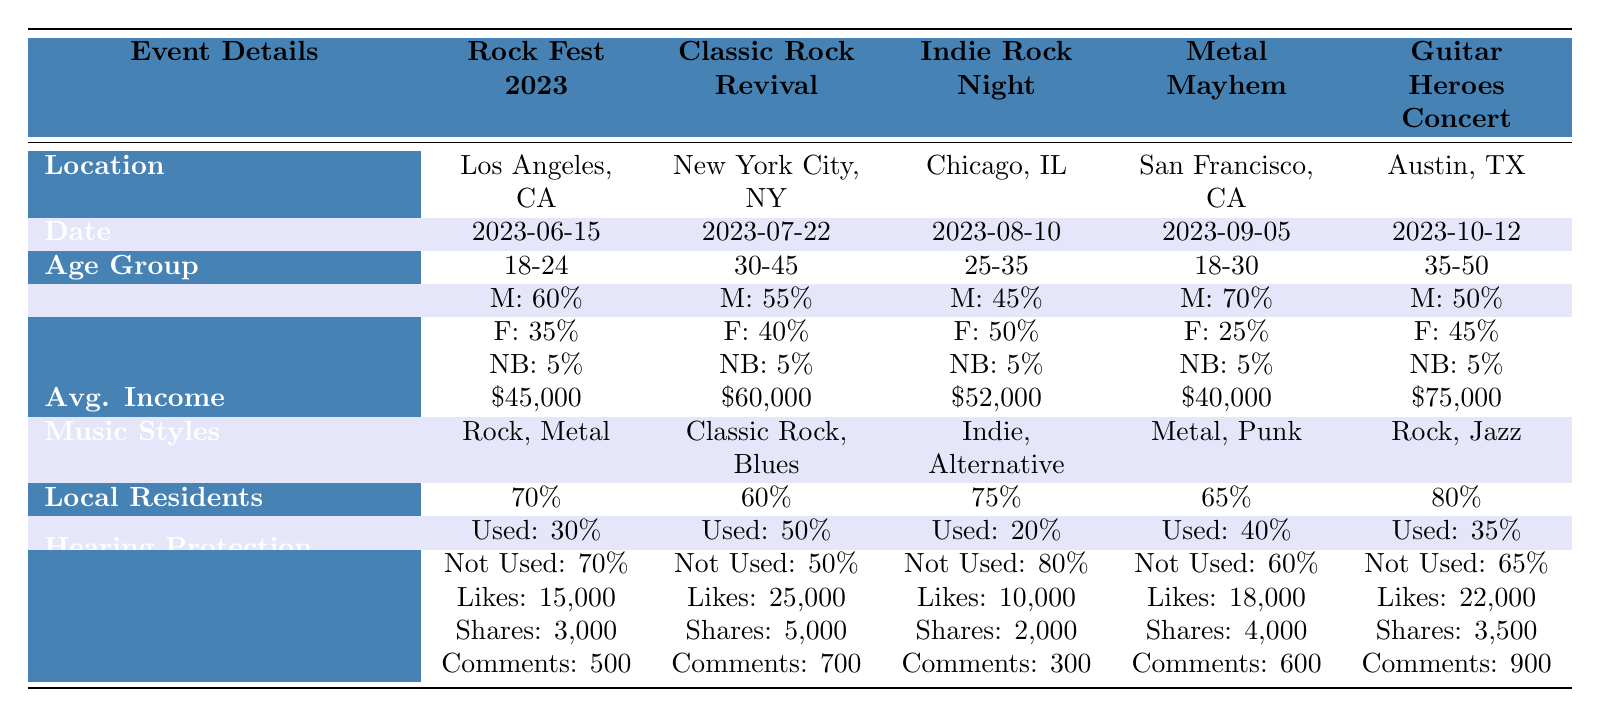What is the average income of the attendees at the "Guitar Heroes Concert"? The average income listed for the "Guitar Heroes Concert" is $75,000 as stated in the table.
Answer: $75,000 Which event had the highest percentage of local residents? By comparing the percentage of local residents for each event, "Guitar Heroes Concert" has the highest at 80%.
Answer: 80% What age group attended the "Indie Rock Night"? The audience age group for "Indie Rock Night" is specified as 25-35 years old in the table.
Answer: 25-35 Did more Male or Female attendees use hearing protection at "Metal Mayhem"? At "Metal Mayhem," 40% used hearing protection, and 70% of the total attendees are Male. The exact count is not given for usage by gender, but the overall usage shows a higher percentage of non-users. This can't be determined with the available data.
Answer: Cannot be determined How do the average incomes compare between "Rock Fest 2023" and "Classic Rock Revival"? The average income at "Rock Fest 2023" is $45,000 and at "Classic Rock Revival" is $60,000. The difference is $60,000 - $45,000 = $15,000, meaning "Classic Rock Revival" has a higher average income by this amount.
Answer: $15,000 What was the total number of Likes across all events listed? Adding the Likes from all events: 15,000 (Rock Fest 2023) + 25,000 (Classic Rock Revival) + 10,000 (Indie Rock Night) + 18,000 (Metal Mayhem) + 22,000 (Guitar Heroes Concert) gives a total of 15,000 + 25,000 + 10,000 + 18,000 + 22,000 = 90,000 Likes.
Answer: 90,000 Is the hearing protection usage for "Indie Rock Night" greater than that for "Rock Fest 2023"? "Indie Rock Night" has 20% using hearing protection, and "Rock Fest 2023" has 30% using protection. Since 30% > 20%, the statement is false.
Answer: No Which primary music style is common between "Rock Fest 2023" and "Metal Mayhem"? Both events feature "Rock" in their primary music styles, as "Rock Fest 2023" focuses on Rock and Metal, while "Metal Mayhem" includes Metal and Punk.
Answer: Rock What percentage of attendees did not use hearing protection at "Guitar Heroes Concert"? In the data, it's stated that 65% of attendees at "Guitar Heroes Concert" did not use hearing protection.
Answer: 65% How does the social media engagement (likes, shares, comments) of "Classic Rock Revival" compare to that of "Indie Rock Night"? For "Classic Rock Revival," there are 25,000 Likes, 5,000 Shares, and 700 Comments compared to “Indie Rock Night” which has 10,000 Likes, 2,000 Shares, and 300 Comments. This clearly shows that "Classic Rock Revival" outperforms "Indie Rock Night" in all aspects of social media engagement.
Answer: Classic Rock Revival outperforms Indie Rock Night in engagement 